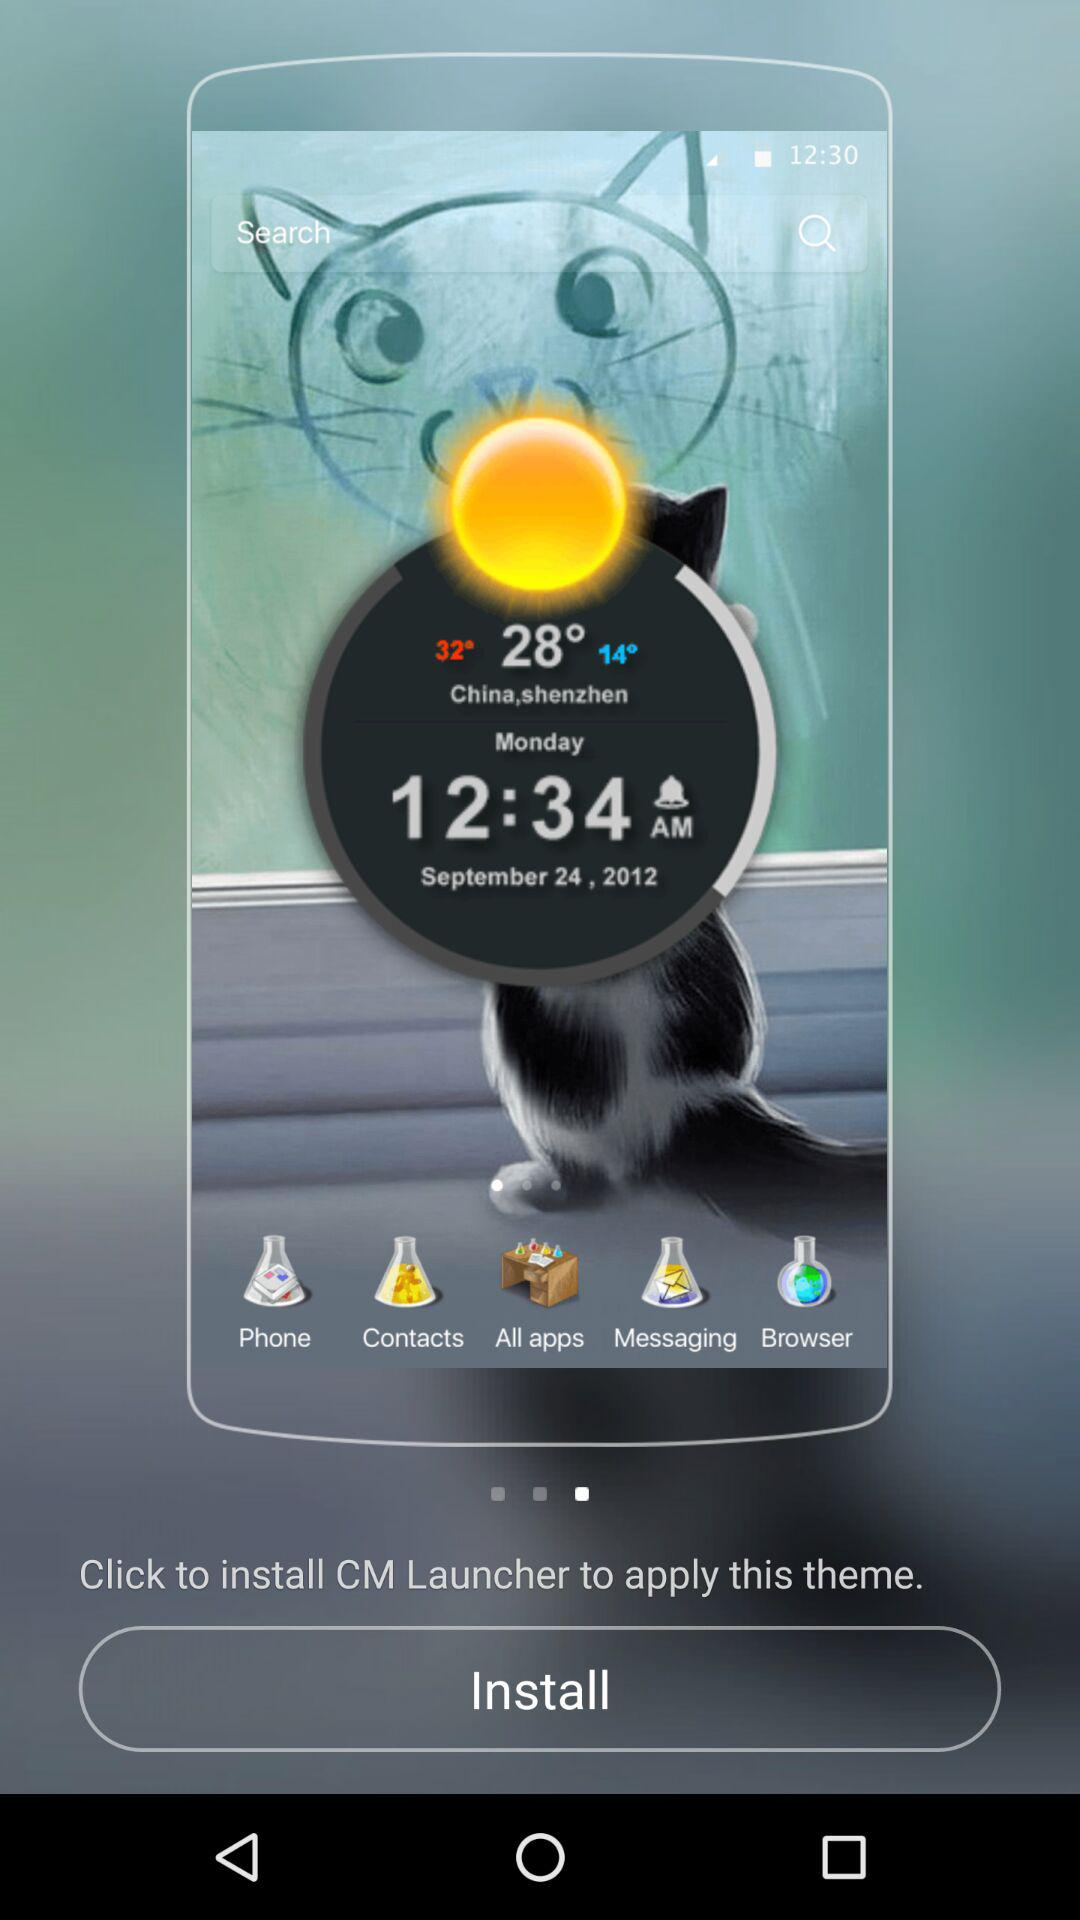What is the given location? The given location is China, Shenzhen. 